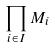<formula> <loc_0><loc_0><loc_500><loc_500>\prod _ { i \in I } M _ { i }</formula> 